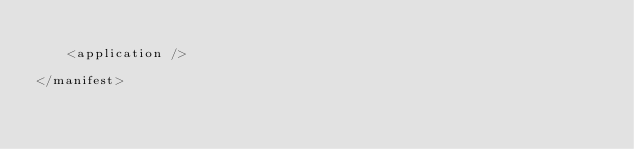<code> <loc_0><loc_0><loc_500><loc_500><_XML_>
    <application />

</manifest>
</code> 